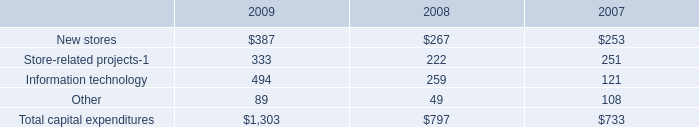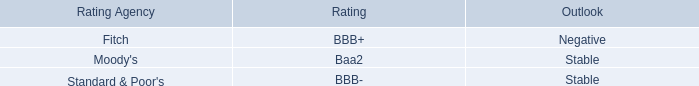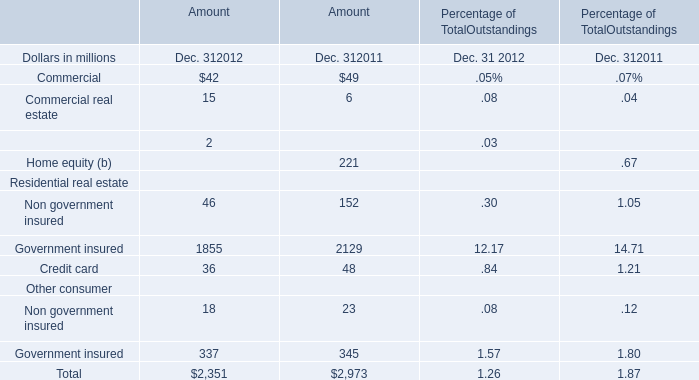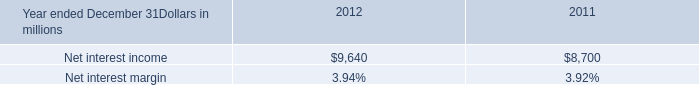Does the value of Non government insured in 2012 greater than that in 2011? 
Answer: No. 